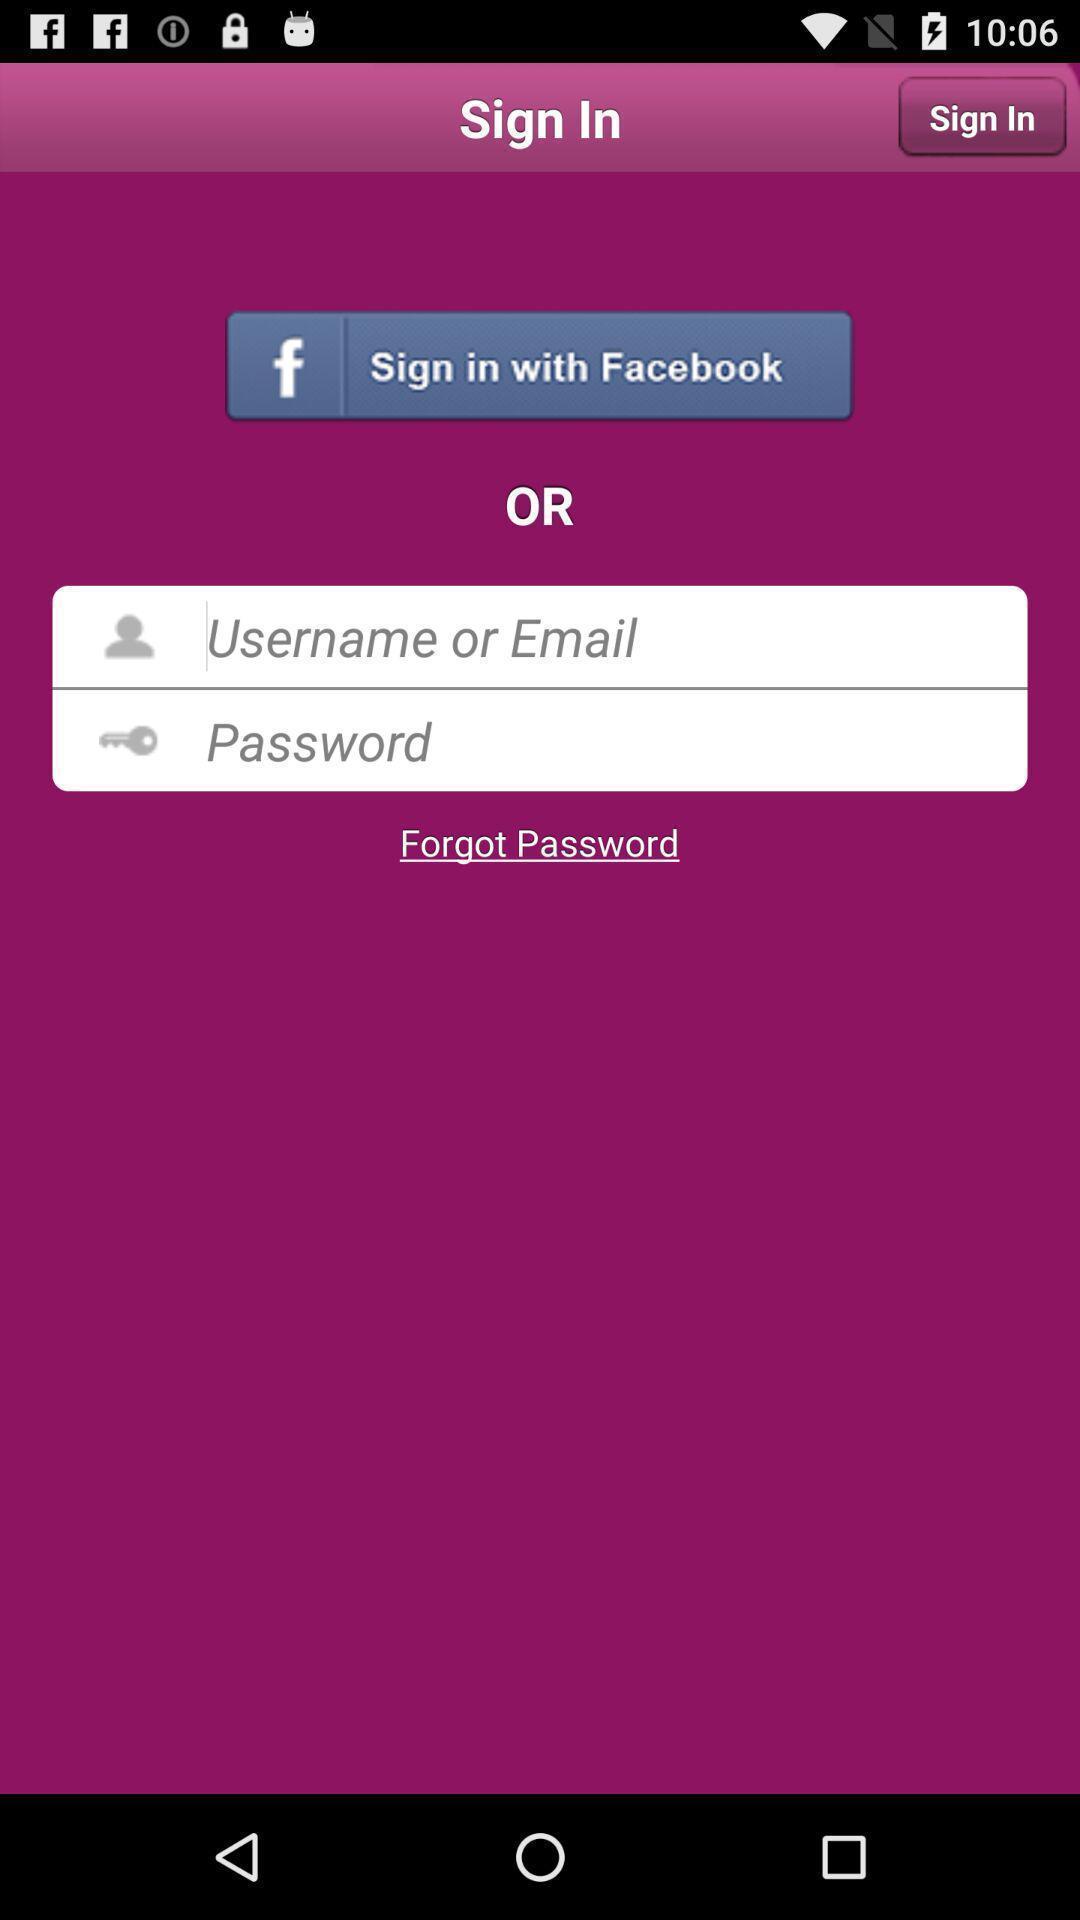Give me a summary of this screen capture. Sign in page. 